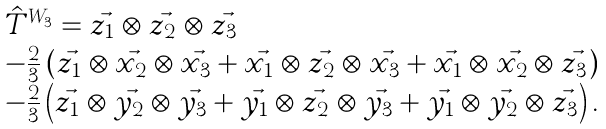Convert formula to latex. <formula><loc_0><loc_0><loc_500><loc_500>\begin{array} { l l c l } \hat { T } ^ { W _ { 3 } } = \vec { z _ { 1 } } \otimes \vec { z _ { 2 } } \otimes \vec { z _ { 3 } } \\ - \frac { 2 } { 3 } \left ( \vec { z _ { 1 } } \otimes \vec { x _ { 2 } } \otimes \vec { x _ { 3 } } + \vec { x _ { 1 } } \otimes \vec { z _ { 2 } } \otimes \vec { x _ { 3 } } + \vec { x _ { 1 } } \otimes \vec { x _ { 2 } } \otimes \vec { z _ { 3 } } \right ) \\ - \frac { 2 } { 3 } \left ( \vec { z _ { 1 } } \otimes \vec { y _ { 2 } } \otimes \vec { y _ { 3 } } + \vec { y _ { 1 } } \otimes \vec { z _ { 2 } } \otimes \vec { y _ { 3 } } + \vec { y _ { 1 } } \otimes \vec { y _ { 2 } } \otimes \vec { z _ { 3 } } \right ) . \end{array}</formula> 